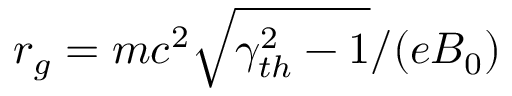<formula> <loc_0><loc_0><loc_500><loc_500>r _ { g } = m c ^ { 2 } \sqrt { \gamma _ { t h } ^ { 2 } - 1 } / ( e B _ { 0 } )</formula> 